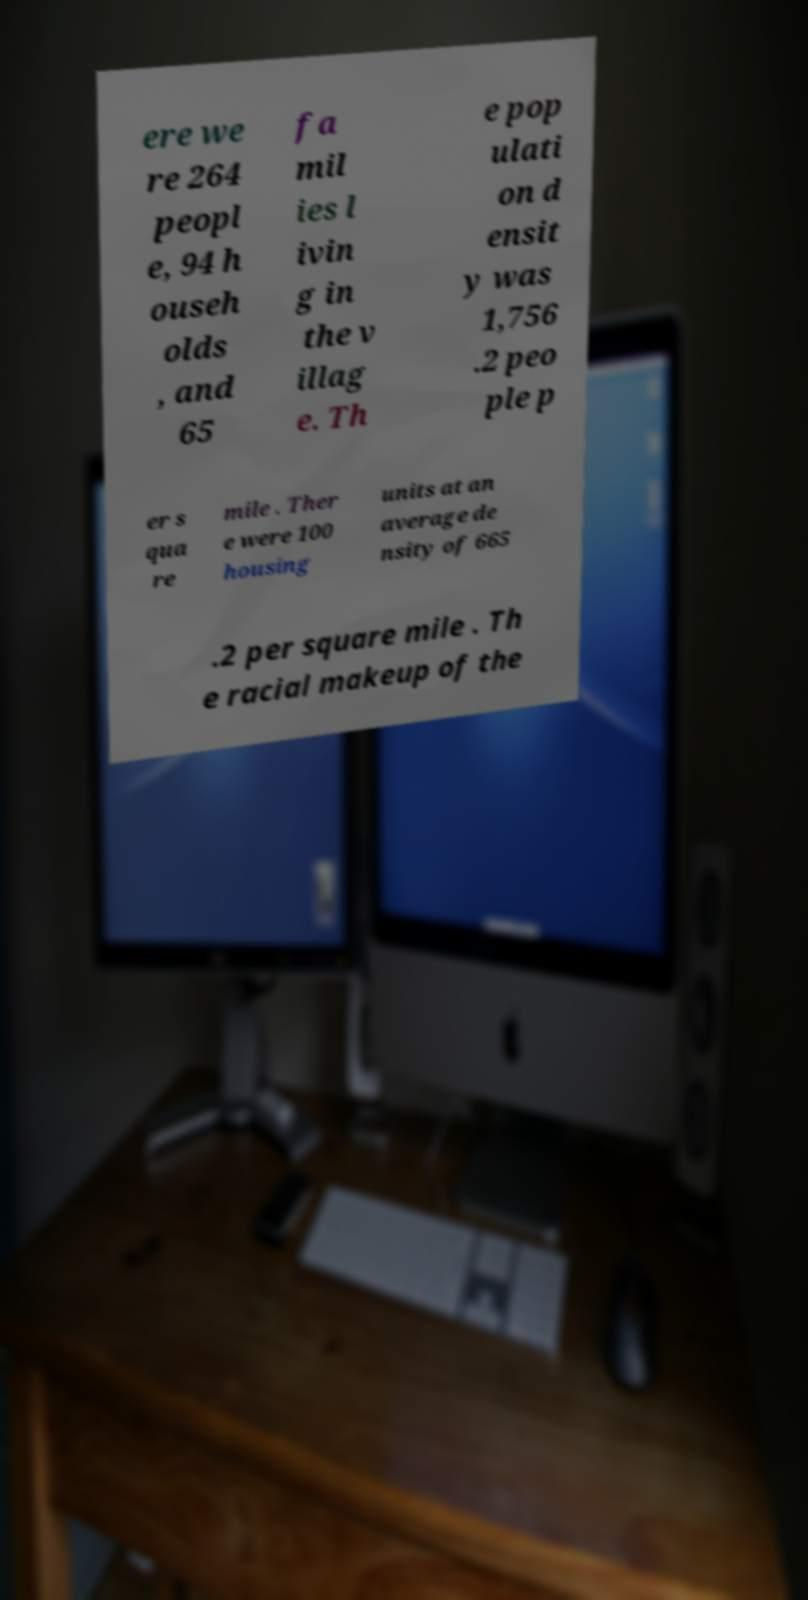There's text embedded in this image that I need extracted. Can you transcribe it verbatim? ere we re 264 peopl e, 94 h ouseh olds , and 65 fa mil ies l ivin g in the v illag e. Th e pop ulati on d ensit y was 1,756 .2 peo ple p er s qua re mile . Ther e were 100 housing units at an average de nsity of 665 .2 per square mile . Th e racial makeup of the 